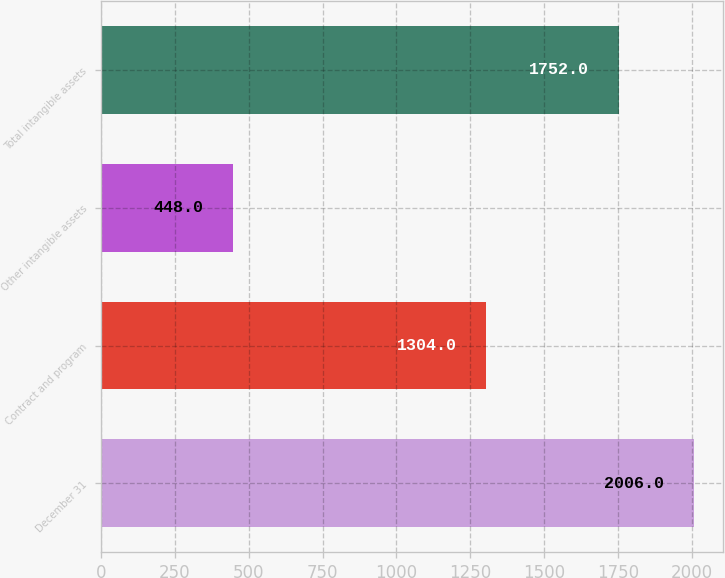Convert chart. <chart><loc_0><loc_0><loc_500><loc_500><bar_chart><fcel>December 31<fcel>Contract and program<fcel>Other intangible assets<fcel>Total intangible assets<nl><fcel>2006<fcel>1304<fcel>448<fcel>1752<nl></chart> 